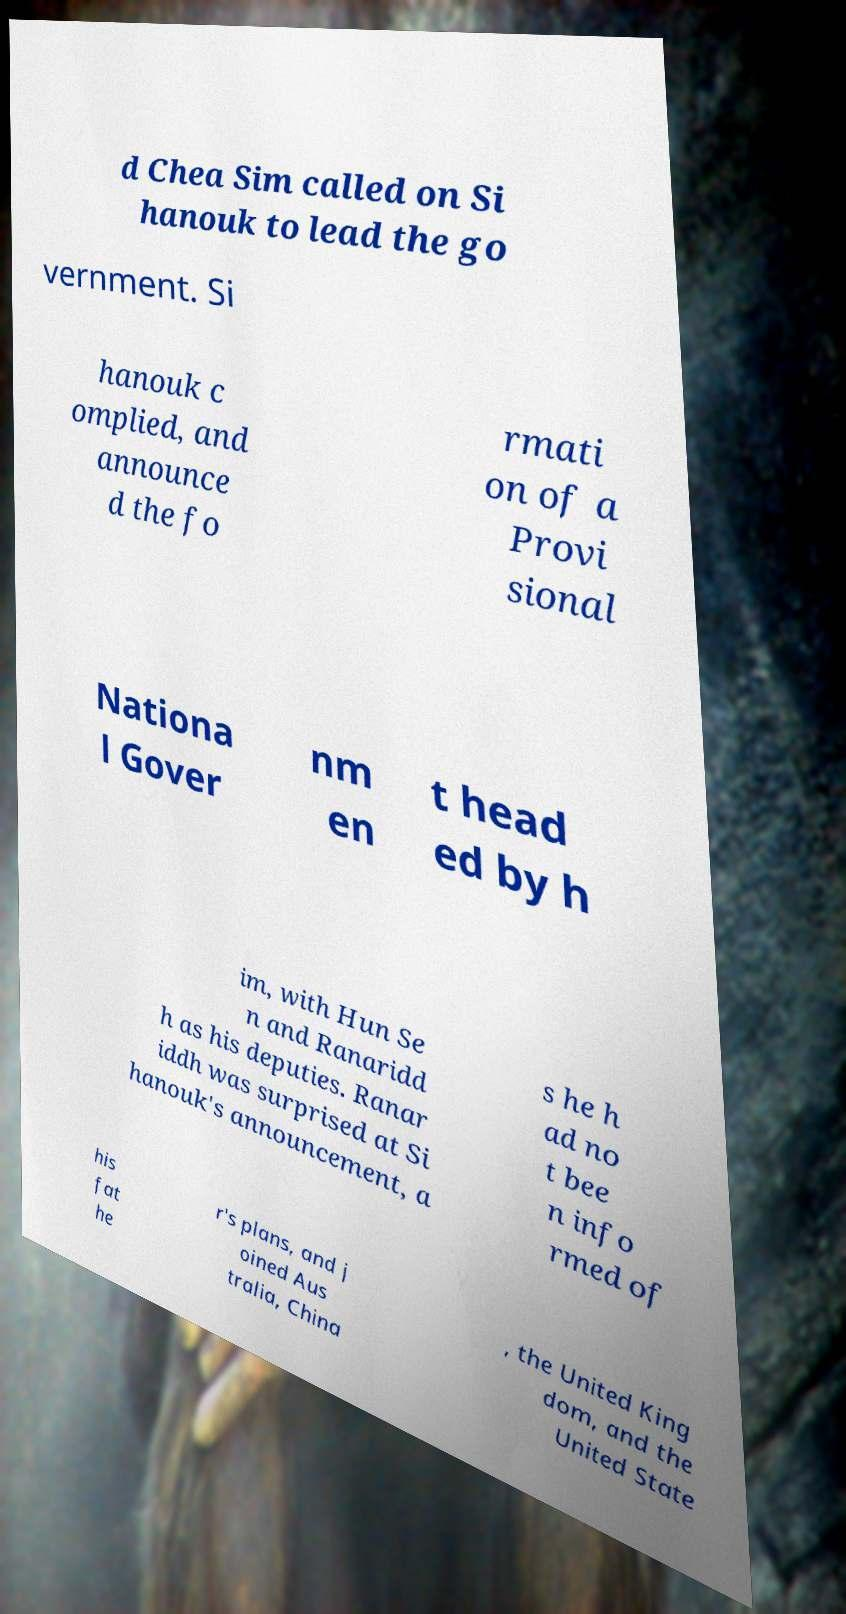Could you extract and type out the text from this image? d Chea Sim called on Si hanouk to lead the go vernment. Si hanouk c omplied, and announce d the fo rmati on of a Provi sional Nationa l Gover nm en t head ed by h im, with Hun Se n and Ranaridd h as his deputies. Ranar iddh was surprised at Si hanouk's announcement, a s he h ad no t bee n info rmed of his fat he r's plans, and j oined Aus tralia, China , the United King dom, and the United State 